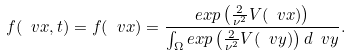<formula> <loc_0><loc_0><loc_500><loc_500>f ( \ v x , t ) = f ( \ v x ) = \frac { e x p \left ( \frac { 2 } { \nu ^ { 2 } } V ( \ v x ) \right ) } { \int _ { \Omega } e x p \left ( \frac { 2 } { \nu ^ { 2 } } V ( \ v y ) \right ) d \ v y } .</formula> 